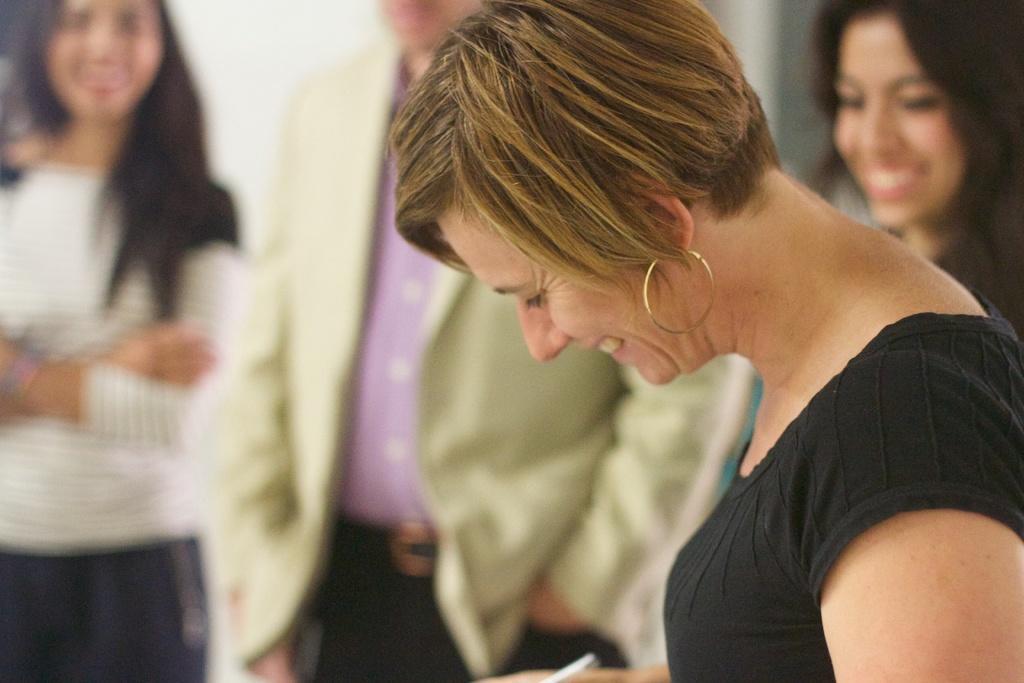Describe this image in one or two sentences. The woman on the right side is standing. She is smiling and she is holding a pen in her hand. Beside her, we see two women and a man are standing. They are smiling. Behind them, we see a white wall. This picture is blurred in the background. 